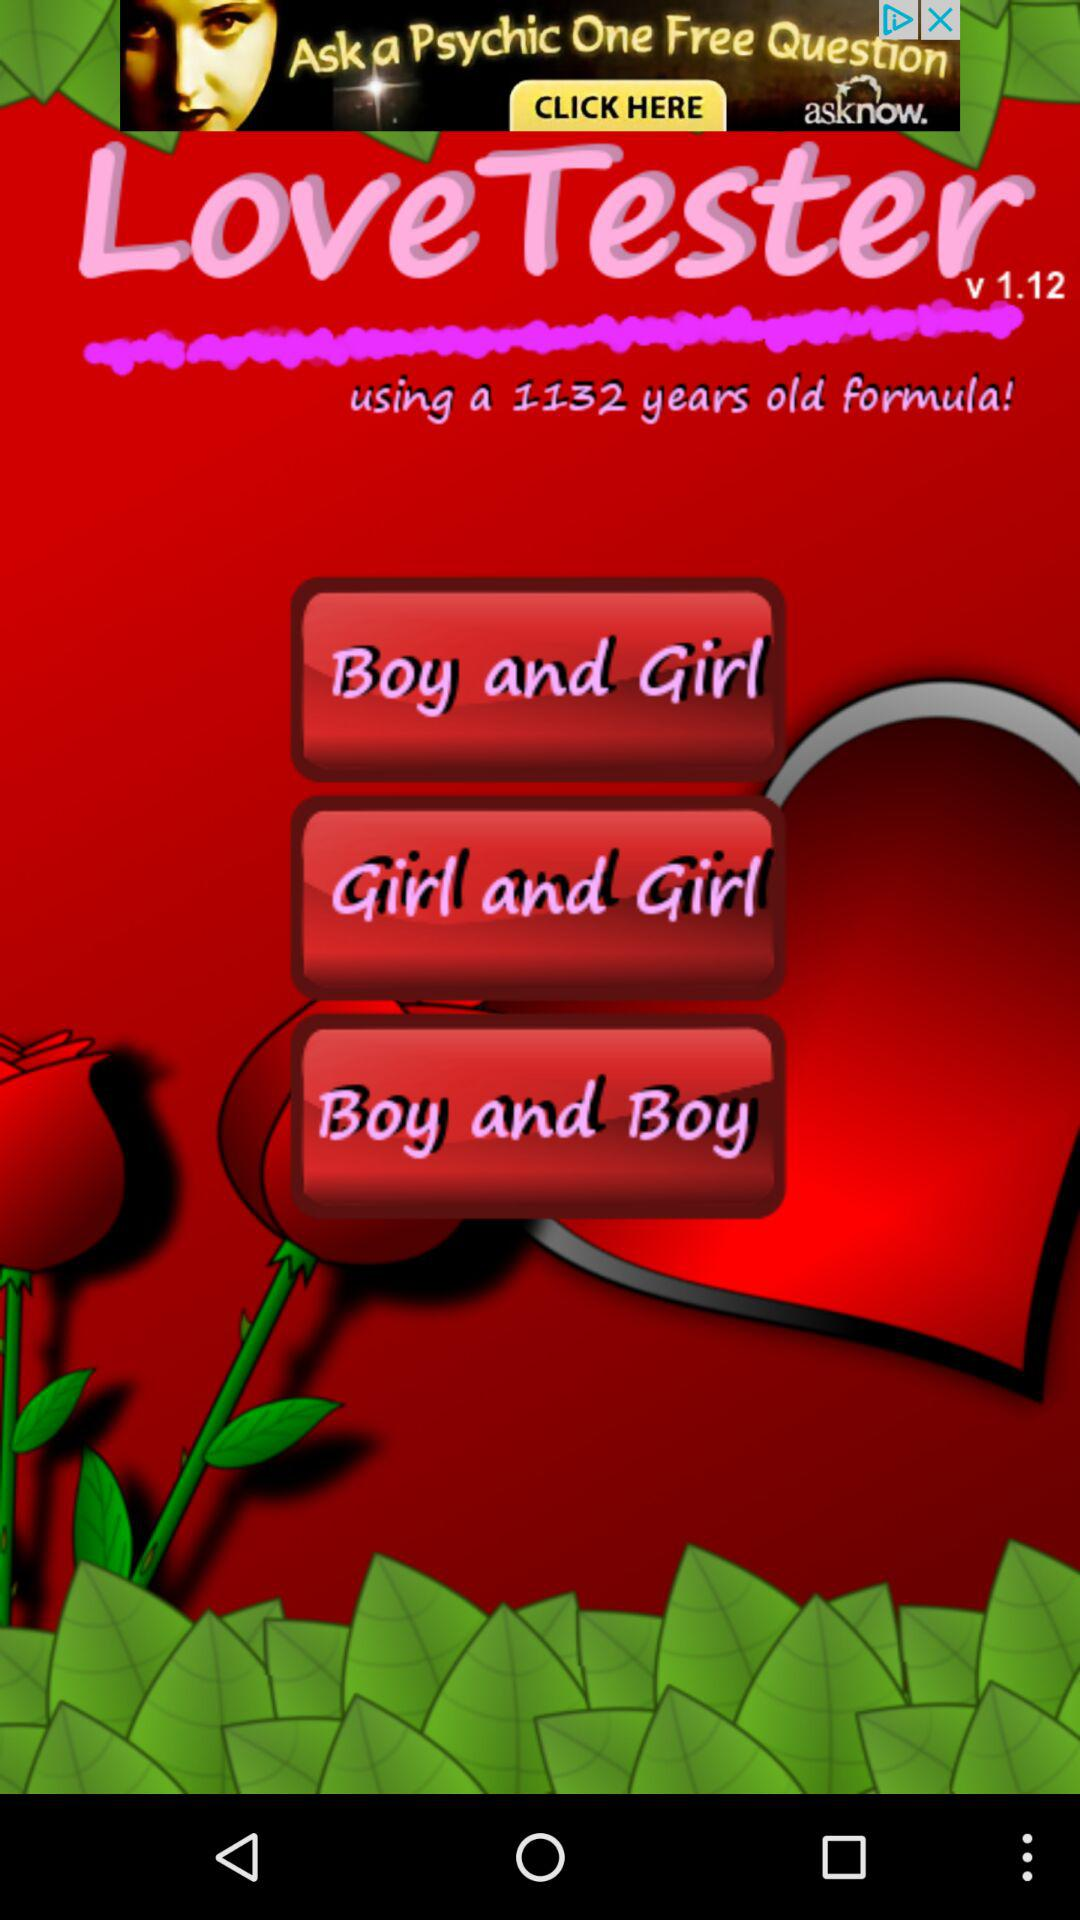Which option is selected?
When the provided information is insufficient, respond with <no answer>. <no answer> 